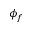Convert formula to latex. <formula><loc_0><loc_0><loc_500><loc_500>\phi _ { f }</formula> 